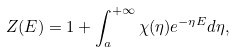<formula> <loc_0><loc_0><loc_500><loc_500>Z ( E ) = 1 + \int _ { a } ^ { + \infty } \chi ( \eta ) e ^ { - \eta E } d \eta ,</formula> 